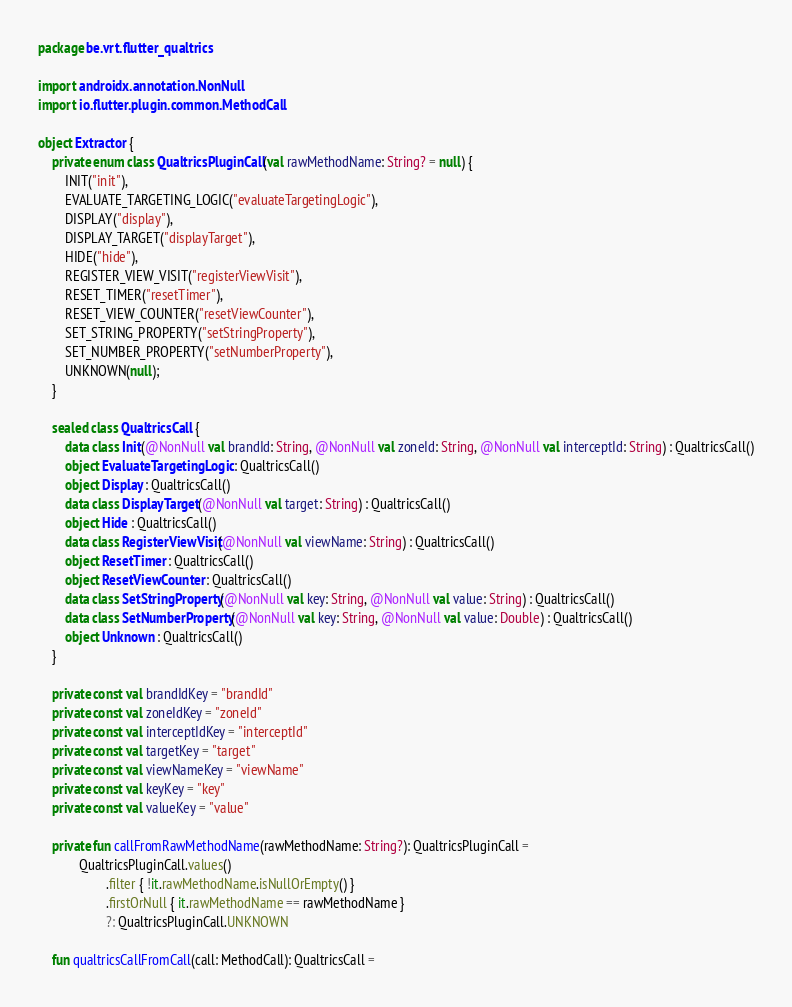<code> <loc_0><loc_0><loc_500><loc_500><_Kotlin_>package be.vrt.flutter_qualtrics

import androidx.annotation.NonNull
import io.flutter.plugin.common.MethodCall

object Extractor {
    private enum class QualtricsPluginCall(val rawMethodName: String? = null) {
        INIT("init"),
        EVALUATE_TARGETING_LOGIC("evaluateTargetingLogic"),
        DISPLAY("display"),
        DISPLAY_TARGET("displayTarget"),
        HIDE("hide"),
        REGISTER_VIEW_VISIT("registerViewVisit"),
        RESET_TIMER("resetTimer"),
        RESET_VIEW_COUNTER("resetViewCounter"),
        SET_STRING_PROPERTY("setStringProperty"),
        SET_NUMBER_PROPERTY("setNumberProperty"),
        UNKNOWN(null);
    }

    sealed class QualtricsCall {
        data class Init(@NonNull val brandId: String, @NonNull val zoneId: String, @NonNull val interceptId: String) : QualtricsCall()
        object EvaluateTargetingLogic : QualtricsCall()
        object Display : QualtricsCall()
        data class DisplayTarget(@NonNull val target: String) : QualtricsCall()
        object Hide : QualtricsCall()
        data class RegisterViewVisit(@NonNull val viewName: String) : QualtricsCall()
        object ResetTimer : QualtricsCall()
        object ResetViewCounter : QualtricsCall()
        data class SetStringProperty(@NonNull val key: String, @NonNull val value: String) : QualtricsCall()
        data class SetNumberProperty(@NonNull val key: String, @NonNull val value: Double) : QualtricsCall()
        object Unknown : QualtricsCall()
    }

    private const val brandIdKey = "brandId"
    private const val zoneIdKey = "zoneId"
    private const val interceptIdKey = "interceptId"
    private const val targetKey = "target"
    private const val viewNameKey = "viewName"
    private const val keyKey = "key"
    private const val valueKey = "value"

    private fun callFromRawMethodName(rawMethodName: String?): QualtricsPluginCall =
            QualtricsPluginCall.values()
                    .filter { !it.rawMethodName.isNullOrEmpty() }
                    .firstOrNull { it.rawMethodName == rawMethodName }
                    ?: QualtricsPluginCall.UNKNOWN

    fun qualtricsCallFromCall(call: MethodCall): QualtricsCall =</code> 